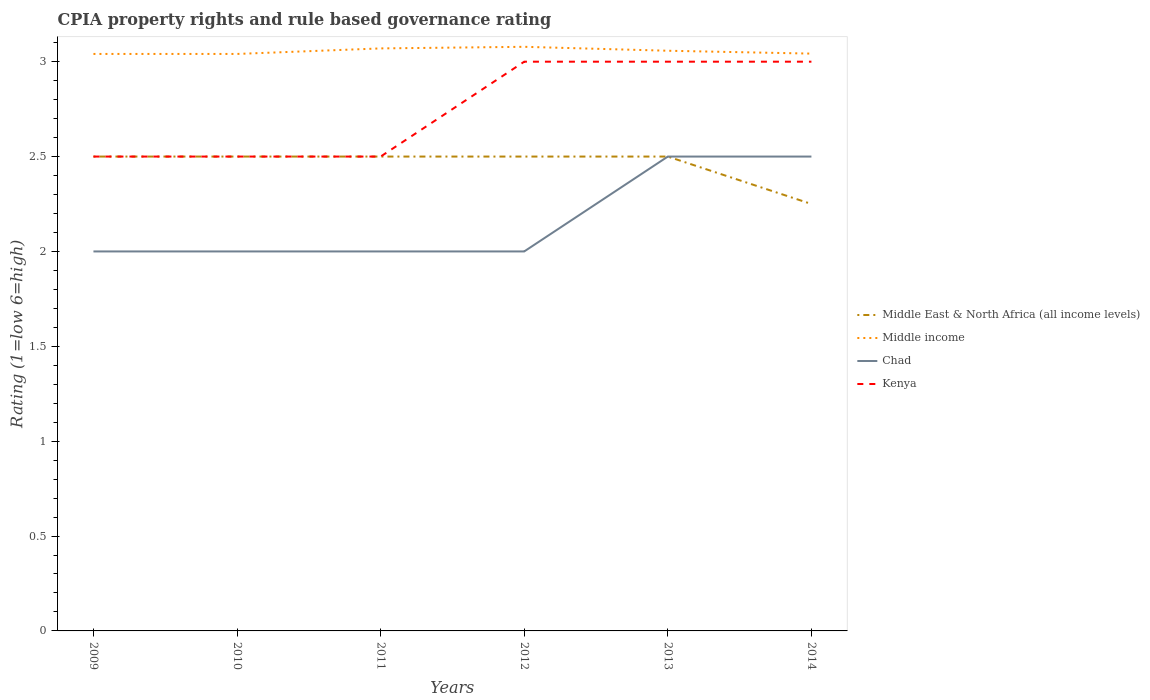Across all years, what is the maximum CPIA rating in Kenya?
Provide a short and direct response. 2.5. What is the difference between the highest and the lowest CPIA rating in Middle East & North Africa (all income levels)?
Offer a terse response. 5. Is the CPIA rating in Chad strictly greater than the CPIA rating in Middle income over the years?
Your response must be concise. Yes. How many lines are there?
Ensure brevity in your answer.  4. What is the difference between two consecutive major ticks on the Y-axis?
Give a very brief answer. 0.5. Are the values on the major ticks of Y-axis written in scientific E-notation?
Provide a short and direct response. No. Where does the legend appear in the graph?
Your response must be concise. Center right. How many legend labels are there?
Your answer should be very brief. 4. What is the title of the graph?
Make the answer very short. CPIA property rights and rule based governance rating. What is the label or title of the X-axis?
Provide a short and direct response. Years. What is the Rating (1=low 6=high) in Middle East & North Africa (all income levels) in 2009?
Give a very brief answer. 2.5. What is the Rating (1=low 6=high) in Middle income in 2009?
Your answer should be very brief. 3.04. What is the Rating (1=low 6=high) of Middle income in 2010?
Make the answer very short. 3.04. What is the Rating (1=low 6=high) of Middle East & North Africa (all income levels) in 2011?
Your answer should be compact. 2.5. What is the Rating (1=low 6=high) in Middle income in 2011?
Offer a terse response. 3.07. What is the Rating (1=low 6=high) of Chad in 2011?
Your answer should be compact. 2. What is the Rating (1=low 6=high) in Middle East & North Africa (all income levels) in 2012?
Provide a short and direct response. 2.5. What is the Rating (1=low 6=high) of Middle income in 2012?
Your response must be concise. 3.08. What is the Rating (1=low 6=high) of Middle East & North Africa (all income levels) in 2013?
Keep it short and to the point. 2.5. What is the Rating (1=low 6=high) in Middle income in 2013?
Give a very brief answer. 3.06. What is the Rating (1=low 6=high) of Chad in 2013?
Your answer should be very brief. 2.5. What is the Rating (1=low 6=high) in Kenya in 2013?
Provide a succinct answer. 3. What is the Rating (1=low 6=high) of Middle East & North Africa (all income levels) in 2014?
Your answer should be compact. 2.25. What is the Rating (1=low 6=high) in Middle income in 2014?
Your answer should be very brief. 3.04. Across all years, what is the maximum Rating (1=low 6=high) of Middle income?
Your response must be concise. 3.08. Across all years, what is the maximum Rating (1=low 6=high) of Chad?
Ensure brevity in your answer.  2.5. Across all years, what is the maximum Rating (1=low 6=high) in Kenya?
Make the answer very short. 3. Across all years, what is the minimum Rating (1=low 6=high) in Middle East & North Africa (all income levels)?
Keep it short and to the point. 2.25. Across all years, what is the minimum Rating (1=low 6=high) of Middle income?
Provide a short and direct response. 3.04. Across all years, what is the minimum Rating (1=low 6=high) of Kenya?
Make the answer very short. 2.5. What is the total Rating (1=low 6=high) in Middle East & North Africa (all income levels) in the graph?
Offer a very short reply. 14.75. What is the total Rating (1=low 6=high) in Middle income in the graph?
Give a very brief answer. 18.33. What is the total Rating (1=low 6=high) of Chad in the graph?
Offer a terse response. 13. What is the total Rating (1=low 6=high) in Kenya in the graph?
Your answer should be compact. 16.5. What is the difference between the Rating (1=low 6=high) of Middle income in 2009 and that in 2010?
Ensure brevity in your answer.  0. What is the difference between the Rating (1=low 6=high) of Kenya in 2009 and that in 2010?
Offer a terse response. 0. What is the difference between the Rating (1=low 6=high) of Middle income in 2009 and that in 2011?
Give a very brief answer. -0.03. What is the difference between the Rating (1=low 6=high) of Chad in 2009 and that in 2011?
Your response must be concise. 0. What is the difference between the Rating (1=low 6=high) of Middle East & North Africa (all income levels) in 2009 and that in 2012?
Your response must be concise. 0. What is the difference between the Rating (1=low 6=high) of Middle income in 2009 and that in 2012?
Provide a short and direct response. -0.04. What is the difference between the Rating (1=low 6=high) of Kenya in 2009 and that in 2012?
Provide a succinct answer. -0.5. What is the difference between the Rating (1=low 6=high) of Middle income in 2009 and that in 2013?
Provide a short and direct response. -0.02. What is the difference between the Rating (1=low 6=high) in Kenya in 2009 and that in 2013?
Provide a succinct answer. -0.5. What is the difference between the Rating (1=low 6=high) of Middle East & North Africa (all income levels) in 2009 and that in 2014?
Give a very brief answer. 0.25. What is the difference between the Rating (1=low 6=high) of Middle income in 2009 and that in 2014?
Your answer should be very brief. -0. What is the difference between the Rating (1=low 6=high) of Chad in 2009 and that in 2014?
Ensure brevity in your answer.  -0.5. What is the difference between the Rating (1=low 6=high) of Kenya in 2009 and that in 2014?
Provide a short and direct response. -0.5. What is the difference between the Rating (1=low 6=high) in Middle income in 2010 and that in 2011?
Your answer should be very brief. -0.03. What is the difference between the Rating (1=low 6=high) of Kenya in 2010 and that in 2011?
Your answer should be compact. 0. What is the difference between the Rating (1=low 6=high) in Middle East & North Africa (all income levels) in 2010 and that in 2012?
Offer a very short reply. 0. What is the difference between the Rating (1=low 6=high) of Middle income in 2010 and that in 2012?
Give a very brief answer. -0.04. What is the difference between the Rating (1=low 6=high) of Kenya in 2010 and that in 2012?
Provide a short and direct response. -0.5. What is the difference between the Rating (1=low 6=high) of Middle East & North Africa (all income levels) in 2010 and that in 2013?
Provide a succinct answer. 0. What is the difference between the Rating (1=low 6=high) of Middle income in 2010 and that in 2013?
Provide a short and direct response. -0.02. What is the difference between the Rating (1=low 6=high) in Chad in 2010 and that in 2013?
Offer a terse response. -0.5. What is the difference between the Rating (1=low 6=high) of Middle income in 2010 and that in 2014?
Offer a terse response. -0. What is the difference between the Rating (1=low 6=high) in Chad in 2010 and that in 2014?
Keep it short and to the point. -0.5. What is the difference between the Rating (1=low 6=high) in Middle East & North Africa (all income levels) in 2011 and that in 2012?
Offer a very short reply. 0. What is the difference between the Rating (1=low 6=high) of Middle income in 2011 and that in 2012?
Your answer should be very brief. -0.01. What is the difference between the Rating (1=low 6=high) of Chad in 2011 and that in 2012?
Your response must be concise. 0. What is the difference between the Rating (1=low 6=high) of Kenya in 2011 and that in 2012?
Provide a succinct answer. -0.5. What is the difference between the Rating (1=low 6=high) of Middle income in 2011 and that in 2013?
Offer a very short reply. 0.01. What is the difference between the Rating (1=low 6=high) in Middle income in 2011 and that in 2014?
Offer a very short reply. 0.03. What is the difference between the Rating (1=low 6=high) in Middle East & North Africa (all income levels) in 2012 and that in 2013?
Ensure brevity in your answer.  0. What is the difference between the Rating (1=low 6=high) of Middle income in 2012 and that in 2013?
Give a very brief answer. 0.02. What is the difference between the Rating (1=low 6=high) of Chad in 2012 and that in 2013?
Ensure brevity in your answer.  -0.5. What is the difference between the Rating (1=low 6=high) of Middle East & North Africa (all income levels) in 2012 and that in 2014?
Your answer should be very brief. 0.25. What is the difference between the Rating (1=low 6=high) of Middle income in 2012 and that in 2014?
Offer a terse response. 0.04. What is the difference between the Rating (1=low 6=high) in Kenya in 2012 and that in 2014?
Make the answer very short. 0. What is the difference between the Rating (1=low 6=high) in Middle East & North Africa (all income levels) in 2013 and that in 2014?
Make the answer very short. 0.25. What is the difference between the Rating (1=low 6=high) in Middle income in 2013 and that in 2014?
Give a very brief answer. 0.02. What is the difference between the Rating (1=low 6=high) in Kenya in 2013 and that in 2014?
Offer a very short reply. 0. What is the difference between the Rating (1=low 6=high) of Middle East & North Africa (all income levels) in 2009 and the Rating (1=low 6=high) of Middle income in 2010?
Give a very brief answer. -0.54. What is the difference between the Rating (1=low 6=high) of Middle income in 2009 and the Rating (1=low 6=high) of Chad in 2010?
Your response must be concise. 1.04. What is the difference between the Rating (1=low 6=high) in Middle income in 2009 and the Rating (1=low 6=high) in Kenya in 2010?
Offer a very short reply. 0.54. What is the difference between the Rating (1=low 6=high) of Middle East & North Africa (all income levels) in 2009 and the Rating (1=low 6=high) of Middle income in 2011?
Offer a very short reply. -0.57. What is the difference between the Rating (1=low 6=high) of Middle East & North Africa (all income levels) in 2009 and the Rating (1=low 6=high) of Chad in 2011?
Give a very brief answer. 0.5. What is the difference between the Rating (1=low 6=high) in Middle East & North Africa (all income levels) in 2009 and the Rating (1=low 6=high) in Kenya in 2011?
Make the answer very short. 0. What is the difference between the Rating (1=low 6=high) of Middle income in 2009 and the Rating (1=low 6=high) of Chad in 2011?
Give a very brief answer. 1.04. What is the difference between the Rating (1=low 6=high) of Middle income in 2009 and the Rating (1=low 6=high) of Kenya in 2011?
Ensure brevity in your answer.  0.54. What is the difference between the Rating (1=low 6=high) in Chad in 2009 and the Rating (1=low 6=high) in Kenya in 2011?
Offer a terse response. -0.5. What is the difference between the Rating (1=low 6=high) in Middle East & North Africa (all income levels) in 2009 and the Rating (1=low 6=high) in Middle income in 2012?
Your answer should be compact. -0.58. What is the difference between the Rating (1=low 6=high) of Middle income in 2009 and the Rating (1=low 6=high) of Chad in 2012?
Your answer should be very brief. 1.04. What is the difference between the Rating (1=low 6=high) in Middle income in 2009 and the Rating (1=low 6=high) in Kenya in 2012?
Offer a very short reply. 0.04. What is the difference between the Rating (1=low 6=high) in Chad in 2009 and the Rating (1=low 6=high) in Kenya in 2012?
Offer a very short reply. -1. What is the difference between the Rating (1=low 6=high) of Middle East & North Africa (all income levels) in 2009 and the Rating (1=low 6=high) of Middle income in 2013?
Ensure brevity in your answer.  -0.56. What is the difference between the Rating (1=low 6=high) in Middle East & North Africa (all income levels) in 2009 and the Rating (1=low 6=high) in Chad in 2013?
Provide a short and direct response. 0. What is the difference between the Rating (1=low 6=high) in Middle income in 2009 and the Rating (1=low 6=high) in Chad in 2013?
Give a very brief answer. 0.54. What is the difference between the Rating (1=low 6=high) in Middle income in 2009 and the Rating (1=low 6=high) in Kenya in 2013?
Provide a succinct answer. 0.04. What is the difference between the Rating (1=low 6=high) in Chad in 2009 and the Rating (1=low 6=high) in Kenya in 2013?
Your answer should be very brief. -1. What is the difference between the Rating (1=low 6=high) of Middle East & North Africa (all income levels) in 2009 and the Rating (1=low 6=high) of Middle income in 2014?
Offer a terse response. -0.54. What is the difference between the Rating (1=low 6=high) in Middle income in 2009 and the Rating (1=low 6=high) in Chad in 2014?
Provide a succinct answer. 0.54. What is the difference between the Rating (1=low 6=high) in Middle income in 2009 and the Rating (1=low 6=high) in Kenya in 2014?
Ensure brevity in your answer.  0.04. What is the difference between the Rating (1=low 6=high) in Chad in 2009 and the Rating (1=low 6=high) in Kenya in 2014?
Give a very brief answer. -1. What is the difference between the Rating (1=low 6=high) of Middle East & North Africa (all income levels) in 2010 and the Rating (1=low 6=high) of Middle income in 2011?
Make the answer very short. -0.57. What is the difference between the Rating (1=low 6=high) of Middle East & North Africa (all income levels) in 2010 and the Rating (1=low 6=high) of Kenya in 2011?
Offer a very short reply. 0. What is the difference between the Rating (1=low 6=high) in Middle income in 2010 and the Rating (1=low 6=high) in Chad in 2011?
Provide a succinct answer. 1.04. What is the difference between the Rating (1=low 6=high) in Middle income in 2010 and the Rating (1=low 6=high) in Kenya in 2011?
Your answer should be very brief. 0.54. What is the difference between the Rating (1=low 6=high) in Middle East & North Africa (all income levels) in 2010 and the Rating (1=low 6=high) in Middle income in 2012?
Make the answer very short. -0.58. What is the difference between the Rating (1=low 6=high) in Middle East & North Africa (all income levels) in 2010 and the Rating (1=low 6=high) in Kenya in 2012?
Your answer should be very brief. -0.5. What is the difference between the Rating (1=low 6=high) in Middle income in 2010 and the Rating (1=low 6=high) in Chad in 2012?
Your answer should be compact. 1.04. What is the difference between the Rating (1=low 6=high) of Middle income in 2010 and the Rating (1=low 6=high) of Kenya in 2012?
Offer a very short reply. 0.04. What is the difference between the Rating (1=low 6=high) in Chad in 2010 and the Rating (1=low 6=high) in Kenya in 2012?
Make the answer very short. -1. What is the difference between the Rating (1=low 6=high) in Middle East & North Africa (all income levels) in 2010 and the Rating (1=low 6=high) in Middle income in 2013?
Your answer should be very brief. -0.56. What is the difference between the Rating (1=low 6=high) in Middle East & North Africa (all income levels) in 2010 and the Rating (1=low 6=high) in Kenya in 2013?
Ensure brevity in your answer.  -0.5. What is the difference between the Rating (1=low 6=high) in Middle income in 2010 and the Rating (1=low 6=high) in Chad in 2013?
Make the answer very short. 0.54. What is the difference between the Rating (1=low 6=high) in Middle income in 2010 and the Rating (1=low 6=high) in Kenya in 2013?
Keep it short and to the point. 0.04. What is the difference between the Rating (1=low 6=high) in Middle East & North Africa (all income levels) in 2010 and the Rating (1=low 6=high) in Middle income in 2014?
Ensure brevity in your answer.  -0.54. What is the difference between the Rating (1=low 6=high) in Middle East & North Africa (all income levels) in 2010 and the Rating (1=low 6=high) in Chad in 2014?
Your answer should be very brief. 0. What is the difference between the Rating (1=low 6=high) of Middle income in 2010 and the Rating (1=low 6=high) of Chad in 2014?
Give a very brief answer. 0.54. What is the difference between the Rating (1=low 6=high) of Middle income in 2010 and the Rating (1=low 6=high) of Kenya in 2014?
Your answer should be very brief. 0.04. What is the difference between the Rating (1=low 6=high) in Chad in 2010 and the Rating (1=low 6=high) in Kenya in 2014?
Your response must be concise. -1. What is the difference between the Rating (1=low 6=high) of Middle East & North Africa (all income levels) in 2011 and the Rating (1=low 6=high) of Middle income in 2012?
Give a very brief answer. -0.58. What is the difference between the Rating (1=low 6=high) in Middle income in 2011 and the Rating (1=low 6=high) in Chad in 2012?
Keep it short and to the point. 1.07. What is the difference between the Rating (1=low 6=high) of Middle income in 2011 and the Rating (1=low 6=high) of Kenya in 2012?
Offer a terse response. 0.07. What is the difference between the Rating (1=low 6=high) of Middle East & North Africa (all income levels) in 2011 and the Rating (1=low 6=high) of Middle income in 2013?
Provide a succinct answer. -0.56. What is the difference between the Rating (1=low 6=high) in Middle East & North Africa (all income levels) in 2011 and the Rating (1=low 6=high) in Chad in 2013?
Your answer should be compact. 0. What is the difference between the Rating (1=low 6=high) in Middle East & North Africa (all income levels) in 2011 and the Rating (1=low 6=high) in Kenya in 2013?
Keep it short and to the point. -0.5. What is the difference between the Rating (1=low 6=high) of Middle income in 2011 and the Rating (1=low 6=high) of Chad in 2013?
Provide a succinct answer. 0.57. What is the difference between the Rating (1=low 6=high) in Middle income in 2011 and the Rating (1=low 6=high) in Kenya in 2013?
Give a very brief answer. 0.07. What is the difference between the Rating (1=low 6=high) of Chad in 2011 and the Rating (1=low 6=high) of Kenya in 2013?
Your answer should be very brief. -1. What is the difference between the Rating (1=low 6=high) of Middle East & North Africa (all income levels) in 2011 and the Rating (1=low 6=high) of Middle income in 2014?
Provide a succinct answer. -0.54. What is the difference between the Rating (1=low 6=high) of Middle East & North Africa (all income levels) in 2011 and the Rating (1=low 6=high) of Kenya in 2014?
Your answer should be compact. -0.5. What is the difference between the Rating (1=low 6=high) in Middle income in 2011 and the Rating (1=low 6=high) in Chad in 2014?
Your response must be concise. 0.57. What is the difference between the Rating (1=low 6=high) of Middle income in 2011 and the Rating (1=low 6=high) of Kenya in 2014?
Offer a terse response. 0.07. What is the difference between the Rating (1=low 6=high) of Chad in 2011 and the Rating (1=low 6=high) of Kenya in 2014?
Provide a succinct answer. -1. What is the difference between the Rating (1=low 6=high) in Middle East & North Africa (all income levels) in 2012 and the Rating (1=low 6=high) in Middle income in 2013?
Provide a short and direct response. -0.56. What is the difference between the Rating (1=low 6=high) of Middle East & North Africa (all income levels) in 2012 and the Rating (1=low 6=high) of Kenya in 2013?
Your answer should be very brief. -0.5. What is the difference between the Rating (1=low 6=high) of Middle income in 2012 and the Rating (1=low 6=high) of Chad in 2013?
Offer a very short reply. 0.58. What is the difference between the Rating (1=low 6=high) in Middle income in 2012 and the Rating (1=low 6=high) in Kenya in 2013?
Your answer should be very brief. 0.08. What is the difference between the Rating (1=low 6=high) in Middle East & North Africa (all income levels) in 2012 and the Rating (1=low 6=high) in Middle income in 2014?
Ensure brevity in your answer.  -0.54. What is the difference between the Rating (1=low 6=high) in Middle East & North Africa (all income levels) in 2012 and the Rating (1=low 6=high) in Chad in 2014?
Provide a short and direct response. 0. What is the difference between the Rating (1=low 6=high) in Middle income in 2012 and the Rating (1=low 6=high) in Chad in 2014?
Ensure brevity in your answer.  0.58. What is the difference between the Rating (1=low 6=high) in Middle income in 2012 and the Rating (1=low 6=high) in Kenya in 2014?
Offer a terse response. 0.08. What is the difference between the Rating (1=low 6=high) in Chad in 2012 and the Rating (1=low 6=high) in Kenya in 2014?
Provide a succinct answer. -1. What is the difference between the Rating (1=low 6=high) of Middle East & North Africa (all income levels) in 2013 and the Rating (1=low 6=high) of Middle income in 2014?
Offer a terse response. -0.54. What is the difference between the Rating (1=low 6=high) of Middle income in 2013 and the Rating (1=low 6=high) of Chad in 2014?
Give a very brief answer. 0.56. What is the difference between the Rating (1=low 6=high) of Middle income in 2013 and the Rating (1=low 6=high) of Kenya in 2014?
Keep it short and to the point. 0.06. What is the average Rating (1=low 6=high) of Middle East & North Africa (all income levels) per year?
Make the answer very short. 2.46. What is the average Rating (1=low 6=high) of Middle income per year?
Your response must be concise. 3.06. What is the average Rating (1=low 6=high) in Chad per year?
Your answer should be compact. 2.17. What is the average Rating (1=low 6=high) in Kenya per year?
Your answer should be compact. 2.75. In the year 2009, what is the difference between the Rating (1=low 6=high) in Middle East & North Africa (all income levels) and Rating (1=low 6=high) in Middle income?
Your answer should be compact. -0.54. In the year 2009, what is the difference between the Rating (1=low 6=high) of Middle income and Rating (1=low 6=high) of Chad?
Give a very brief answer. 1.04. In the year 2009, what is the difference between the Rating (1=low 6=high) in Middle income and Rating (1=low 6=high) in Kenya?
Keep it short and to the point. 0.54. In the year 2009, what is the difference between the Rating (1=low 6=high) in Chad and Rating (1=low 6=high) in Kenya?
Make the answer very short. -0.5. In the year 2010, what is the difference between the Rating (1=low 6=high) of Middle East & North Africa (all income levels) and Rating (1=low 6=high) of Middle income?
Provide a succinct answer. -0.54. In the year 2010, what is the difference between the Rating (1=low 6=high) of Middle East & North Africa (all income levels) and Rating (1=low 6=high) of Chad?
Your answer should be very brief. 0.5. In the year 2010, what is the difference between the Rating (1=low 6=high) in Middle income and Rating (1=low 6=high) in Chad?
Keep it short and to the point. 1.04. In the year 2010, what is the difference between the Rating (1=low 6=high) of Middle income and Rating (1=low 6=high) of Kenya?
Your answer should be very brief. 0.54. In the year 2010, what is the difference between the Rating (1=low 6=high) in Chad and Rating (1=low 6=high) in Kenya?
Ensure brevity in your answer.  -0.5. In the year 2011, what is the difference between the Rating (1=low 6=high) in Middle East & North Africa (all income levels) and Rating (1=low 6=high) in Middle income?
Your response must be concise. -0.57. In the year 2011, what is the difference between the Rating (1=low 6=high) of Middle East & North Africa (all income levels) and Rating (1=low 6=high) of Chad?
Provide a succinct answer. 0.5. In the year 2011, what is the difference between the Rating (1=low 6=high) of Middle East & North Africa (all income levels) and Rating (1=low 6=high) of Kenya?
Give a very brief answer. 0. In the year 2011, what is the difference between the Rating (1=low 6=high) in Middle income and Rating (1=low 6=high) in Chad?
Your answer should be very brief. 1.07. In the year 2011, what is the difference between the Rating (1=low 6=high) of Middle income and Rating (1=low 6=high) of Kenya?
Provide a short and direct response. 0.57. In the year 2011, what is the difference between the Rating (1=low 6=high) in Chad and Rating (1=low 6=high) in Kenya?
Your answer should be compact. -0.5. In the year 2012, what is the difference between the Rating (1=low 6=high) of Middle East & North Africa (all income levels) and Rating (1=low 6=high) of Middle income?
Offer a very short reply. -0.58. In the year 2012, what is the difference between the Rating (1=low 6=high) in Middle East & North Africa (all income levels) and Rating (1=low 6=high) in Chad?
Offer a very short reply. 0.5. In the year 2012, what is the difference between the Rating (1=low 6=high) of Middle East & North Africa (all income levels) and Rating (1=low 6=high) of Kenya?
Provide a short and direct response. -0.5. In the year 2012, what is the difference between the Rating (1=low 6=high) in Middle income and Rating (1=low 6=high) in Chad?
Offer a terse response. 1.08. In the year 2012, what is the difference between the Rating (1=low 6=high) of Middle income and Rating (1=low 6=high) of Kenya?
Provide a short and direct response. 0.08. In the year 2012, what is the difference between the Rating (1=low 6=high) in Chad and Rating (1=low 6=high) in Kenya?
Your response must be concise. -1. In the year 2013, what is the difference between the Rating (1=low 6=high) of Middle East & North Africa (all income levels) and Rating (1=low 6=high) of Middle income?
Your answer should be compact. -0.56. In the year 2013, what is the difference between the Rating (1=low 6=high) of Middle East & North Africa (all income levels) and Rating (1=low 6=high) of Chad?
Provide a succinct answer. 0. In the year 2013, what is the difference between the Rating (1=low 6=high) in Middle East & North Africa (all income levels) and Rating (1=low 6=high) in Kenya?
Ensure brevity in your answer.  -0.5. In the year 2013, what is the difference between the Rating (1=low 6=high) of Middle income and Rating (1=low 6=high) of Chad?
Make the answer very short. 0.56. In the year 2013, what is the difference between the Rating (1=low 6=high) in Middle income and Rating (1=low 6=high) in Kenya?
Offer a terse response. 0.06. In the year 2013, what is the difference between the Rating (1=low 6=high) of Chad and Rating (1=low 6=high) of Kenya?
Provide a short and direct response. -0.5. In the year 2014, what is the difference between the Rating (1=low 6=high) in Middle East & North Africa (all income levels) and Rating (1=low 6=high) in Middle income?
Your answer should be very brief. -0.79. In the year 2014, what is the difference between the Rating (1=low 6=high) in Middle East & North Africa (all income levels) and Rating (1=low 6=high) in Chad?
Keep it short and to the point. -0.25. In the year 2014, what is the difference between the Rating (1=low 6=high) in Middle East & North Africa (all income levels) and Rating (1=low 6=high) in Kenya?
Give a very brief answer. -0.75. In the year 2014, what is the difference between the Rating (1=low 6=high) of Middle income and Rating (1=low 6=high) of Chad?
Your answer should be very brief. 0.54. In the year 2014, what is the difference between the Rating (1=low 6=high) of Middle income and Rating (1=low 6=high) of Kenya?
Offer a terse response. 0.04. What is the ratio of the Rating (1=low 6=high) of Middle income in 2009 to that in 2010?
Give a very brief answer. 1. What is the ratio of the Rating (1=low 6=high) in Chad in 2009 to that in 2010?
Your answer should be very brief. 1. What is the ratio of the Rating (1=low 6=high) of Middle income in 2009 to that in 2011?
Your answer should be very brief. 0.99. What is the ratio of the Rating (1=low 6=high) of Kenya in 2009 to that in 2011?
Offer a terse response. 1. What is the ratio of the Rating (1=low 6=high) in Middle East & North Africa (all income levels) in 2009 to that in 2012?
Provide a short and direct response. 1. What is the ratio of the Rating (1=low 6=high) of Middle income in 2009 to that in 2012?
Give a very brief answer. 0.99. What is the ratio of the Rating (1=low 6=high) of Chad in 2009 to that in 2012?
Keep it short and to the point. 1. What is the ratio of the Rating (1=low 6=high) of Kenya in 2009 to that in 2012?
Offer a very short reply. 0.83. What is the ratio of the Rating (1=low 6=high) in Middle income in 2009 to that in 2013?
Offer a terse response. 0.99. What is the ratio of the Rating (1=low 6=high) in Kenya in 2009 to that in 2013?
Keep it short and to the point. 0.83. What is the ratio of the Rating (1=low 6=high) of Chad in 2009 to that in 2014?
Keep it short and to the point. 0.8. What is the ratio of the Rating (1=low 6=high) in Kenya in 2009 to that in 2014?
Ensure brevity in your answer.  0.83. What is the ratio of the Rating (1=low 6=high) of Middle East & North Africa (all income levels) in 2010 to that in 2011?
Keep it short and to the point. 1. What is the ratio of the Rating (1=low 6=high) in Kenya in 2010 to that in 2011?
Give a very brief answer. 1. What is the ratio of the Rating (1=low 6=high) in Middle East & North Africa (all income levels) in 2010 to that in 2012?
Offer a very short reply. 1. What is the ratio of the Rating (1=low 6=high) in Middle income in 2010 to that in 2012?
Provide a succinct answer. 0.99. What is the ratio of the Rating (1=low 6=high) in Middle East & North Africa (all income levels) in 2010 to that in 2013?
Provide a short and direct response. 1. What is the ratio of the Rating (1=low 6=high) of Middle income in 2010 to that in 2013?
Make the answer very short. 0.99. What is the ratio of the Rating (1=low 6=high) of Chad in 2010 to that in 2013?
Offer a terse response. 0.8. What is the ratio of the Rating (1=low 6=high) of Chad in 2010 to that in 2014?
Your response must be concise. 0.8. What is the ratio of the Rating (1=low 6=high) in Middle East & North Africa (all income levels) in 2011 to that in 2012?
Ensure brevity in your answer.  1. What is the ratio of the Rating (1=low 6=high) of Chad in 2011 to that in 2012?
Offer a terse response. 1. What is the ratio of the Rating (1=low 6=high) of Middle East & North Africa (all income levels) in 2011 to that in 2013?
Give a very brief answer. 1. What is the ratio of the Rating (1=low 6=high) of Middle income in 2011 to that in 2013?
Offer a terse response. 1. What is the ratio of the Rating (1=low 6=high) in Kenya in 2011 to that in 2013?
Offer a very short reply. 0.83. What is the ratio of the Rating (1=low 6=high) in Kenya in 2011 to that in 2014?
Provide a succinct answer. 0.83. What is the ratio of the Rating (1=low 6=high) of Middle income in 2012 to that in 2013?
Provide a short and direct response. 1.01. What is the ratio of the Rating (1=low 6=high) in Chad in 2012 to that in 2013?
Your response must be concise. 0.8. What is the ratio of the Rating (1=low 6=high) in Kenya in 2012 to that in 2013?
Offer a very short reply. 1. What is the ratio of the Rating (1=low 6=high) in Middle East & North Africa (all income levels) in 2012 to that in 2014?
Provide a short and direct response. 1.11. What is the ratio of the Rating (1=low 6=high) of Middle income in 2012 to that in 2014?
Give a very brief answer. 1.01. What is the ratio of the Rating (1=low 6=high) in Middle East & North Africa (all income levels) in 2013 to that in 2014?
Your answer should be very brief. 1.11. What is the ratio of the Rating (1=low 6=high) of Kenya in 2013 to that in 2014?
Your response must be concise. 1. What is the difference between the highest and the second highest Rating (1=low 6=high) in Middle East & North Africa (all income levels)?
Your response must be concise. 0. What is the difference between the highest and the second highest Rating (1=low 6=high) in Middle income?
Make the answer very short. 0.01. What is the difference between the highest and the second highest Rating (1=low 6=high) in Kenya?
Provide a succinct answer. 0. What is the difference between the highest and the lowest Rating (1=low 6=high) in Middle income?
Provide a succinct answer. 0.04. What is the difference between the highest and the lowest Rating (1=low 6=high) of Kenya?
Make the answer very short. 0.5. 